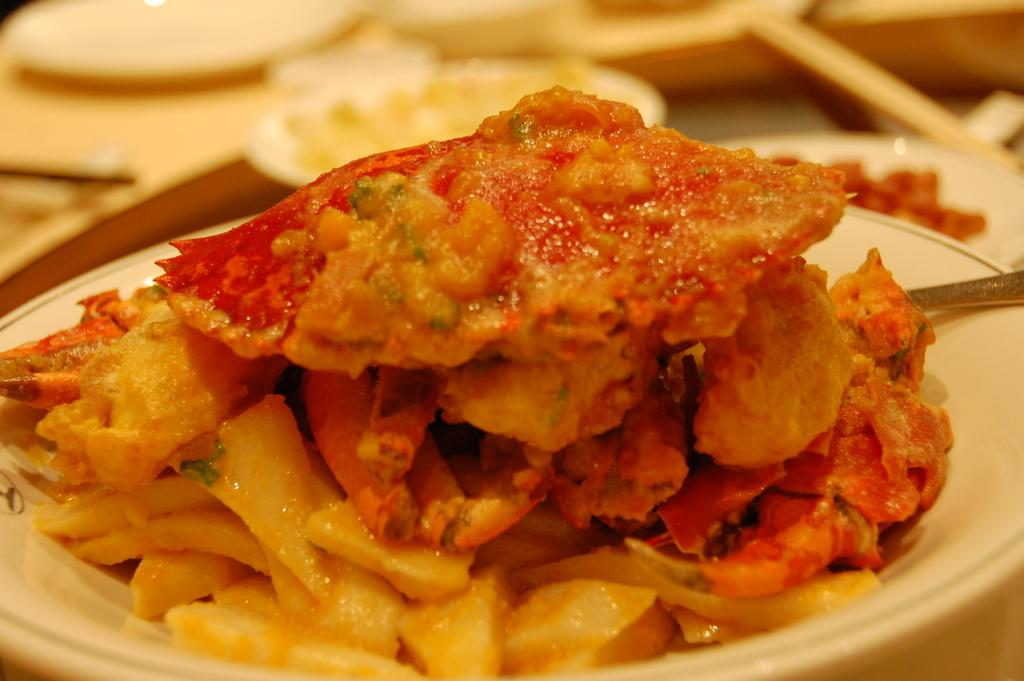What type of objects can be seen in the image? There are food items in the image. What colors are the food items? The food items are in red and cream color. Can you describe the background of the image? The background of the image is blurred. What type of invention is being used in the image? There is no invention present in the image; it features food items in red and cream color with a blurred background. 